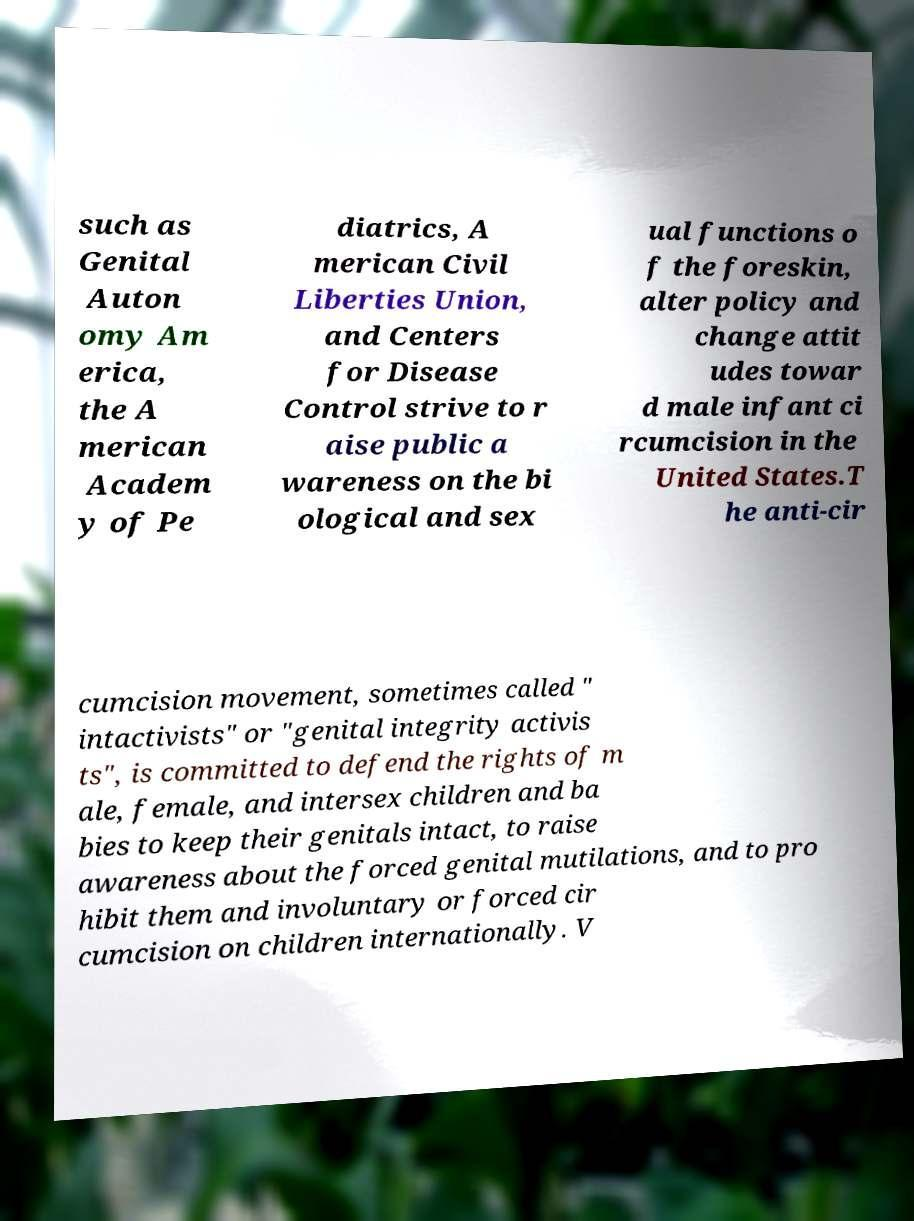What messages or text are displayed in this image? I need them in a readable, typed format. such as Genital Auton omy Am erica, the A merican Academ y of Pe diatrics, A merican Civil Liberties Union, and Centers for Disease Control strive to r aise public a wareness on the bi ological and sex ual functions o f the foreskin, alter policy and change attit udes towar d male infant ci rcumcision in the United States.T he anti-cir cumcision movement, sometimes called " intactivists" or "genital integrity activis ts", is committed to defend the rights of m ale, female, and intersex children and ba bies to keep their genitals intact, to raise awareness about the forced genital mutilations, and to pro hibit them and involuntary or forced cir cumcision on children internationally. V 